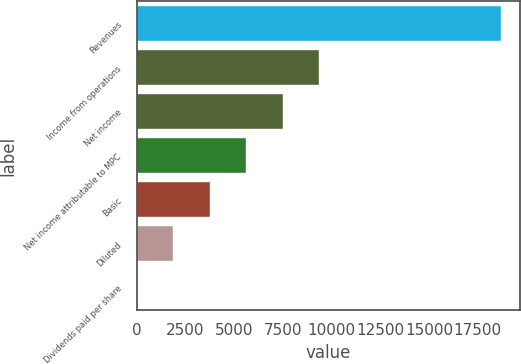Convert chart to OTSL. <chart><loc_0><loc_0><loc_500><loc_500><bar_chart><fcel>Revenues<fcel>Income from operations<fcel>Net income<fcel>Net income attributable to MPC<fcel>Basic<fcel>Diluted<fcel>Dividends paid per share<nl><fcel>18716<fcel>9358.17<fcel>7486.6<fcel>5615.03<fcel>3743.46<fcel>1871.89<fcel>0.32<nl></chart> 